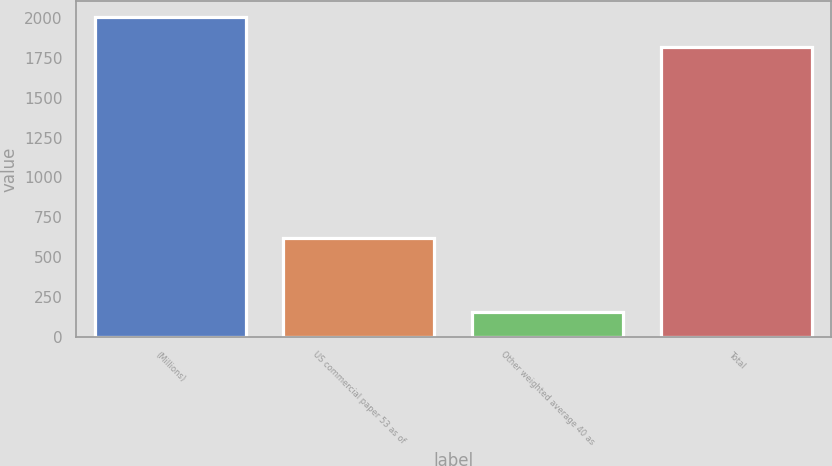Convert chart to OTSL. <chart><loc_0><loc_0><loc_500><loc_500><bar_chart><fcel>(Millions)<fcel>US commercial paper 53 as of<fcel>Other weighted average 40 as<fcel>Total<nl><fcel>2007<fcel>617<fcel>154<fcel>1818<nl></chart> 